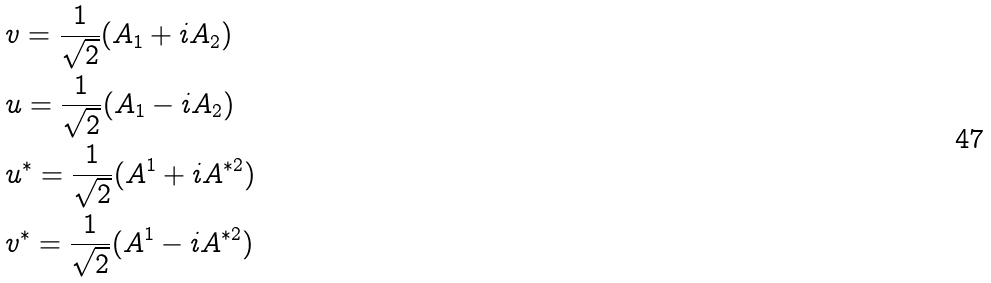Convert formula to latex. <formula><loc_0><loc_0><loc_500><loc_500>& v = \frac { 1 } { \sqrt { 2 } } ( A _ { 1 } + i A _ { 2 } ) \\ & u = \frac { 1 } { \sqrt { 2 } } ( A _ { 1 } - i A _ { 2 } ) \\ & u ^ { * } = \frac { 1 } { \sqrt { 2 } } ( A ^ { 1 } + i A ^ { * 2 } ) \\ & v ^ { * } = \frac { 1 } { \sqrt { 2 } } ( A ^ { 1 } - i A ^ { * 2 } )</formula> 